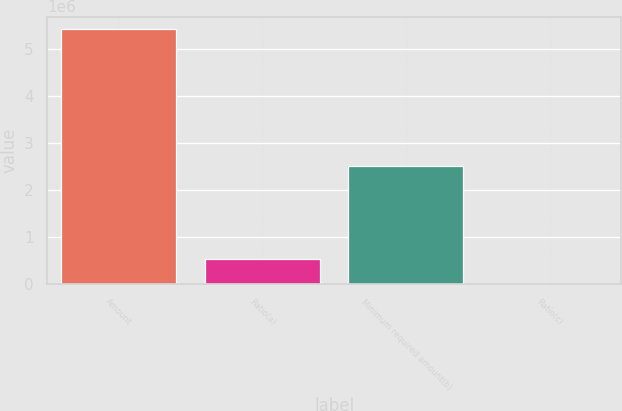<chart> <loc_0><loc_0><loc_500><loc_500><bar_chart><fcel>Amount<fcel>Ratio(a)<fcel>Minimum required amount(b)<fcel>Ratio(c)<nl><fcel>5.40633e+06<fcel>540641<fcel>2.5089e+06<fcel>8.46<nl></chart> 